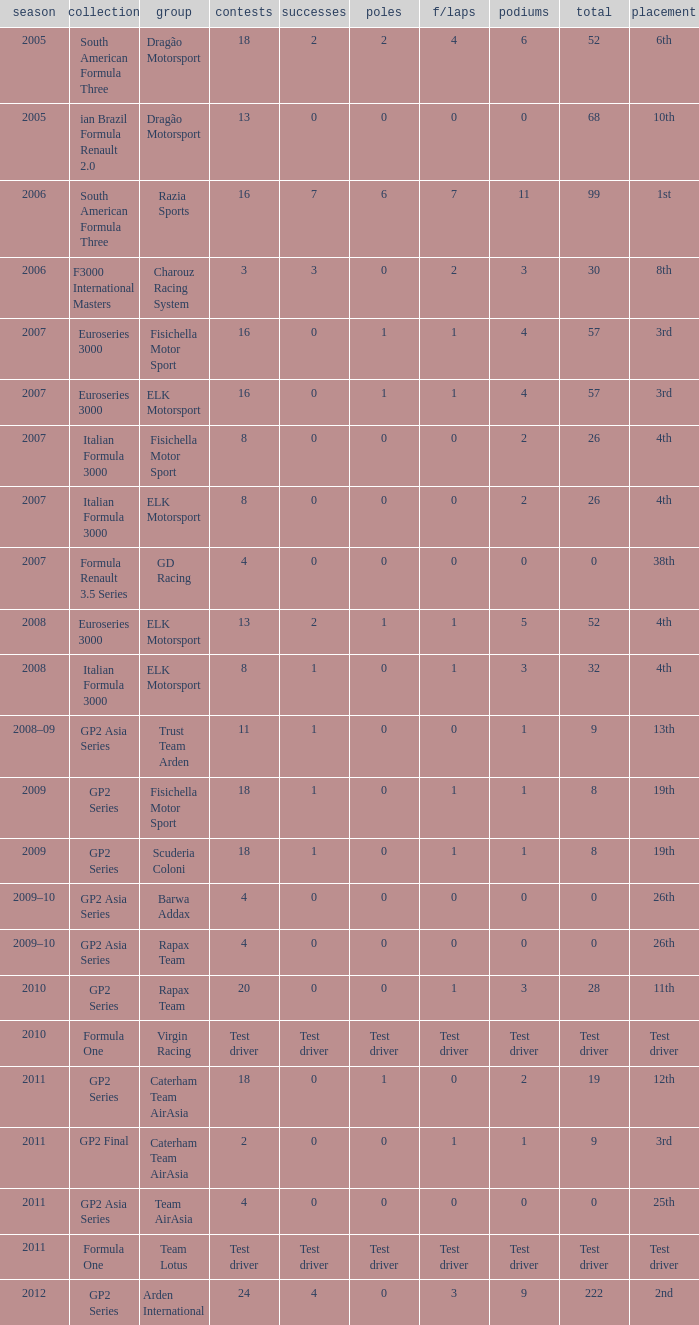What was his position in 2009 with 1 win? 19th, 19th. 